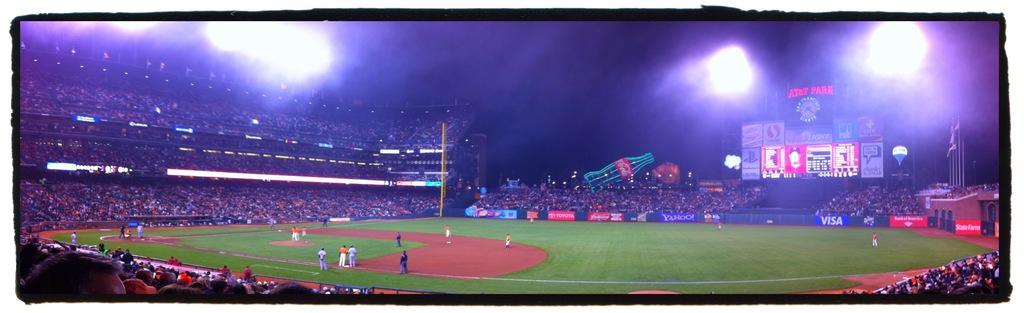What is the main structure visible in the picture? There is a stadium in the picture. What can be seen inside the stadium? There are people, flags, a scoreboard, posters, and lighting visible inside the stadium. What might the flags represent? The flags could represent teams, countries, or organizations. What is used to display the scores during a game or event? There is a scoreboard in the stadium for displaying scores. What type of steel is used to construct the stadium in the image? There is no information about the type of steel used to construct the stadium in the image. What reward can be seen being given to the players in the image? There is no reward being given to the players in the image; it only shows the stadium and its contents. 